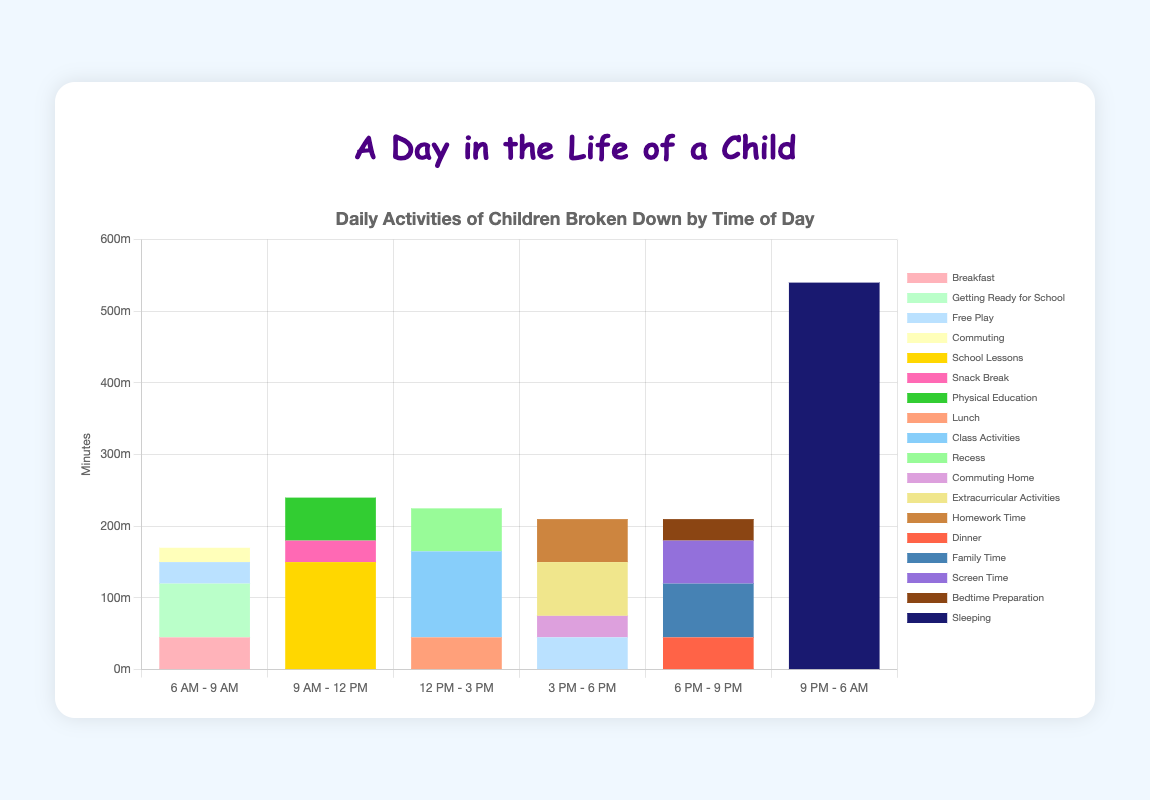What time period has the most time dedicated to commuting? First, we need to look at the sections dedicated to commuting across all time periods. We see that commuting is present in "6 AM - 9 AM" with 20 minutes and in "3 PM - 6 PM" with 30 minutes. Comparing these, the time period "3 PM - 6 PM" has more time dedicated to commuting.
Answer: 3 PM - 6 PM How much total time is spent on school-related activities (school lessons, class activities, recess) between 9 AM and 3 PM? First, identify the relevant school-related activities and their time periods. Between "9 AM - 12 PM", school lessons = 150 minutes, and between "12 PM - 3 PM", class activities = 120 minutes and recess = 60 minutes. Summing these up, 150 + 120 + 60 = 330 minutes.
Answer: 330 minutes Which activity takes the largest amount of time during the "6 PM - 9 PM" period? We need to look at the specific activities during the "6 PM - 9 PM" time period. The activities are dinner (45 minutes), family time (75 minutes), screen time (60 minutes), and bedtime preparation (30 minutes). Comparing these, family time takes the largest amount of time with 75 minutes.
Answer: Family time Is more time spent on extracurricular activities or on homework time in the overall day? We need to look at both activity times across all time periods. Extracurricular activities are only in "3 PM - 6 PM" with 75 minutes, and homework time is also in "3 PM - 6 PM" with 60 minutes. Comparing these, 75 minutes are spent on extracurricular activities, while 60 minutes are spent on homework time.
Answer: Extracurricular activities What's the total number of minutes spent on meals (breakfast, lunch, dinner) throughout the day? Add the time spent on all meals: Breakfast during "6 AM - 9 AM" is 45 minutes, lunch during "12 PM - 3 PM" is 45 minutes, and dinner during "6 PM - 9 PM" is 45 minutes. The total is 45 + 45 + 45 = 135 minutes.
Answer: 135 minutes 